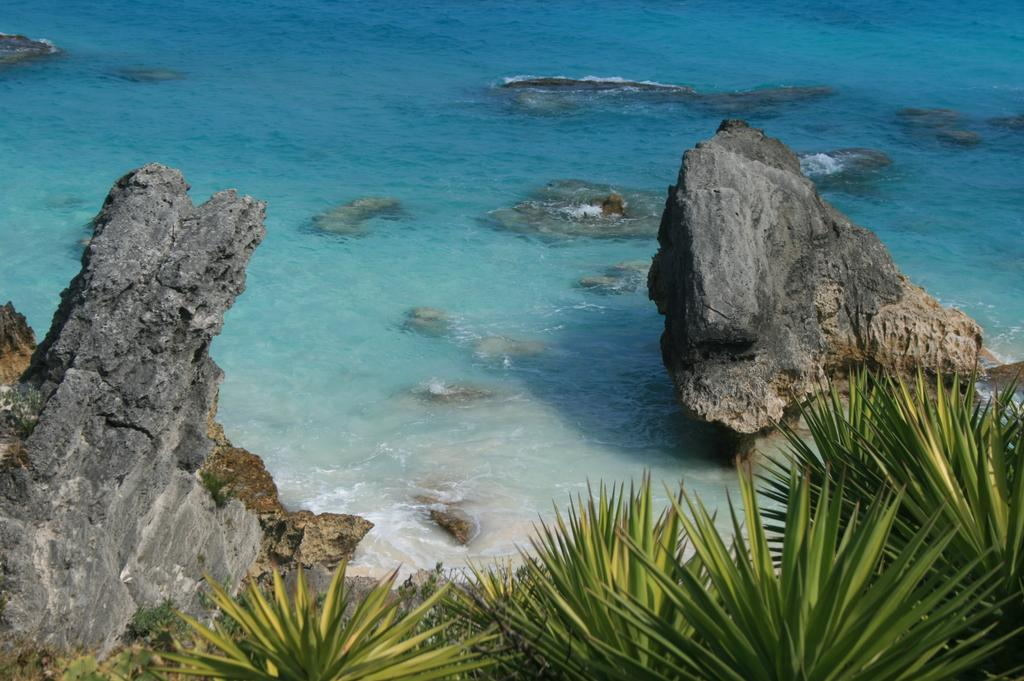What type of vegetation can be seen in the front of the image? There are plants in the front of the image. What material is present in the center of the image? There are stones in the center of the image. What natural element is visible in the background of the image? There is water visible in the background of the image. Can you tell me how many ducks are swimming in the water in the image? There are no ducks present in the image; it only features plants, stones, and water. What type of pen is used to draw the plants in the image? The image is a photograph and does not involve any drawing or pen usage. 